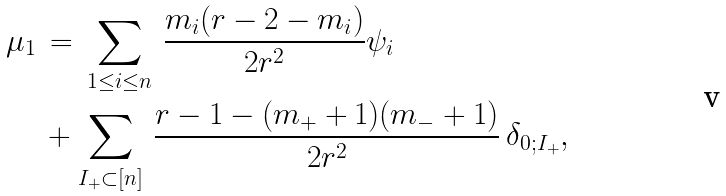Convert formula to latex. <formula><loc_0><loc_0><loc_500><loc_500>\mu _ { 1 } \, & = \, \sum _ { 1 \leq i \leq n } \, \frac { m _ { i } ( r - 2 - m _ { i } ) } { 2 r ^ { 2 } } \psi _ { i } \\ & + \sum _ { I _ { + } \subset [ n ] } \, \frac { r - 1 - ( m _ { + } + 1 ) ( m _ { - } + 1 ) } { 2 r ^ { 2 } } \, \delta _ { 0 ; I _ { + } } , \\</formula> 